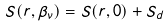<formula> <loc_0><loc_0><loc_500><loc_500>S ( r , \beta _ { \nu } ) = S ( r , 0 ) + S _ { d }</formula> 